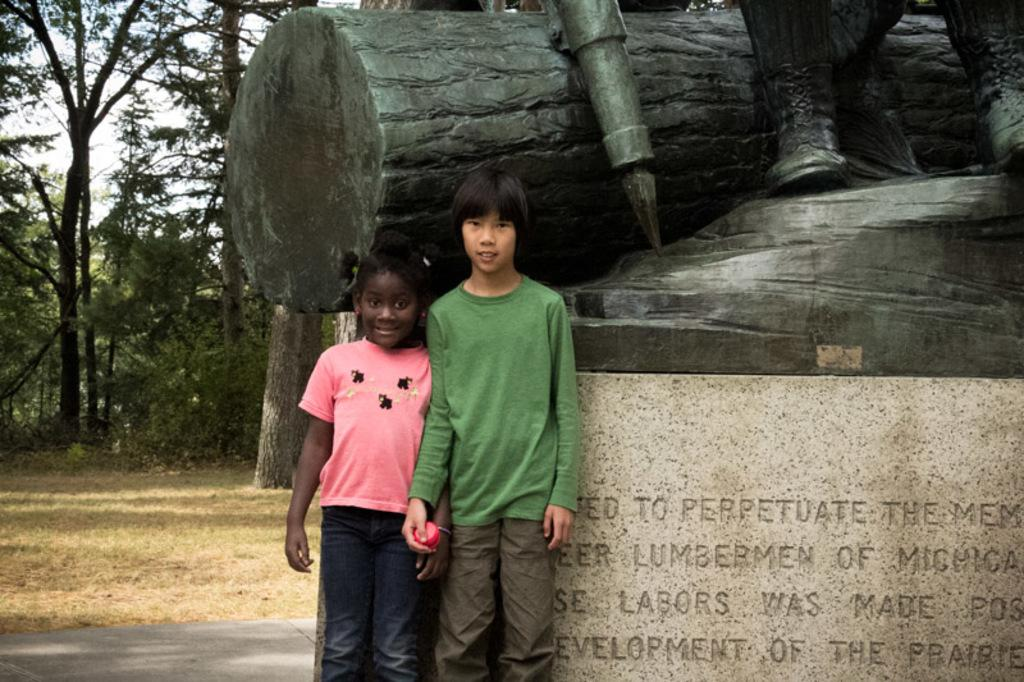What can be seen in the image? There are children standing in the image. Where are the children standing? The children are standing on the floor. What can be seen in the background of the image? There is a statue, a pedestal with text, the ground, trees, and the sky visible in the background of the image. What type of line is being drawn by the children in the image? There is no line being drawn by the children in the image; they are simply standing. 